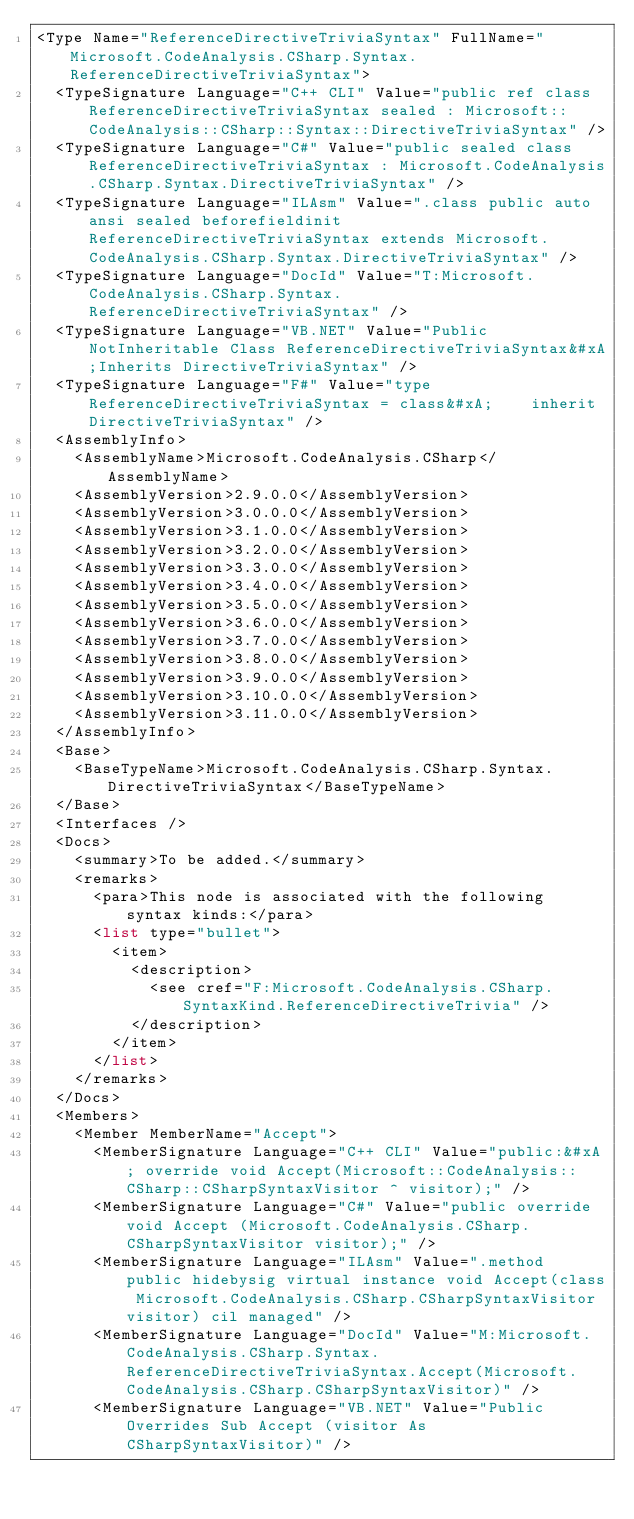<code> <loc_0><loc_0><loc_500><loc_500><_XML_><Type Name="ReferenceDirectiveTriviaSyntax" FullName="Microsoft.CodeAnalysis.CSharp.Syntax.ReferenceDirectiveTriviaSyntax">
  <TypeSignature Language="C++ CLI" Value="public ref class ReferenceDirectiveTriviaSyntax sealed : Microsoft::CodeAnalysis::CSharp::Syntax::DirectiveTriviaSyntax" />
  <TypeSignature Language="C#" Value="public sealed class ReferenceDirectiveTriviaSyntax : Microsoft.CodeAnalysis.CSharp.Syntax.DirectiveTriviaSyntax" />
  <TypeSignature Language="ILAsm" Value=".class public auto ansi sealed beforefieldinit ReferenceDirectiveTriviaSyntax extends Microsoft.CodeAnalysis.CSharp.Syntax.DirectiveTriviaSyntax" />
  <TypeSignature Language="DocId" Value="T:Microsoft.CodeAnalysis.CSharp.Syntax.ReferenceDirectiveTriviaSyntax" />
  <TypeSignature Language="VB.NET" Value="Public NotInheritable Class ReferenceDirectiveTriviaSyntax&#xA;Inherits DirectiveTriviaSyntax" />
  <TypeSignature Language="F#" Value="type ReferenceDirectiveTriviaSyntax = class&#xA;    inherit DirectiveTriviaSyntax" />
  <AssemblyInfo>
    <AssemblyName>Microsoft.CodeAnalysis.CSharp</AssemblyName>
    <AssemblyVersion>2.9.0.0</AssemblyVersion>
    <AssemblyVersion>3.0.0.0</AssemblyVersion>
    <AssemblyVersion>3.1.0.0</AssemblyVersion>
    <AssemblyVersion>3.2.0.0</AssemblyVersion>
    <AssemblyVersion>3.3.0.0</AssemblyVersion>
    <AssemblyVersion>3.4.0.0</AssemblyVersion>
    <AssemblyVersion>3.5.0.0</AssemblyVersion>
    <AssemblyVersion>3.6.0.0</AssemblyVersion>
    <AssemblyVersion>3.7.0.0</AssemblyVersion>
    <AssemblyVersion>3.8.0.0</AssemblyVersion>
    <AssemblyVersion>3.9.0.0</AssemblyVersion>
    <AssemblyVersion>3.10.0.0</AssemblyVersion>
    <AssemblyVersion>3.11.0.0</AssemblyVersion>
  </AssemblyInfo>
  <Base>
    <BaseTypeName>Microsoft.CodeAnalysis.CSharp.Syntax.DirectiveTriviaSyntax</BaseTypeName>
  </Base>
  <Interfaces />
  <Docs>
    <summary>To be added.</summary>
    <remarks>
      <para>This node is associated with the following syntax kinds:</para>
      <list type="bullet">
        <item>
          <description>
            <see cref="F:Microsoft.CodeAnalysis.CSharp.SyntaxKind.ReferenceDirectiveTrivia" />
          </description>
        </item>
      </list>
    </remarks>
  </Docs>
  <Members>
    <Member MemberName="Accept">
      <MemberSignature Language="C++ CLI" Value="public:&#xA; override void Accept(Microsoft::CodeAnalysis::CSharp::CSharpSyntaxVisitor ^ visitor);" />
      <MemberSignature Language="C#" Value="public override void Accept (Microsoft.CodeAnalysis.CSharp.CSharpSyntaxVisitor visitor);" />
      <MemberSignature Language="ILAsm" Value=".method public hidebysig virtual instance void Accept(class Microsoft.CodeAnalysis.CSharp.CSharpSyntaxVisitor visitor) cil managed" />
      <MemberSignature Language="DocId" Value="M:Microsoft.CodeAnalysis.CSharp.Syntax.ReferenceDirectiveTriviaSyntax.Accept(Microsoft.CodeAnalysis.CSharp.CSharpSyntaxVisitor)" />
      <MemberSignature Language="VB.NET" Value="Public Overrides Sub Accept (visitor As CSharpSyntaxVisitor)" /></code> 